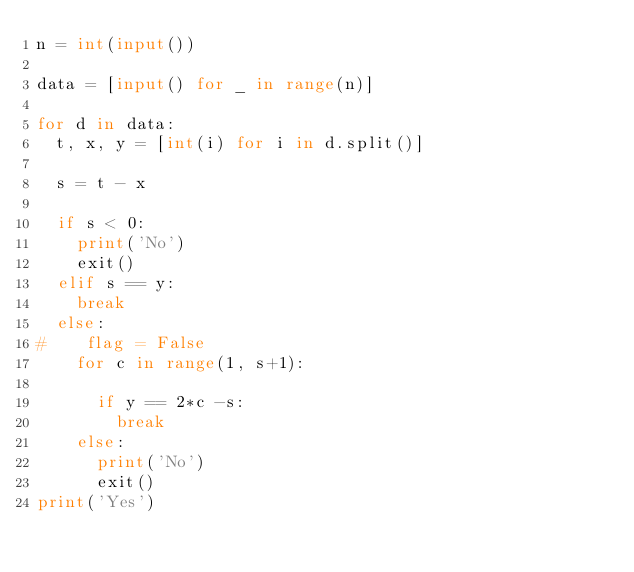Convert code to text. <code><loc_0><loc_0><loc_500><loc_500><_Python_>n = int(input())

data = [input() for _ in range(n)]

for d in data:
  t, x, y = [int(i) for i in d.split()]
  
  s = t - x
  
  if s < 0:
    print('No')
    exit()
  elif s == y:
    break
  else:
#    flag = False
    for c in range(1, s+1):
      
      if y == 2*c -s:
        break
    else:
      print('No')
      exit()
print('Yes')</code> 